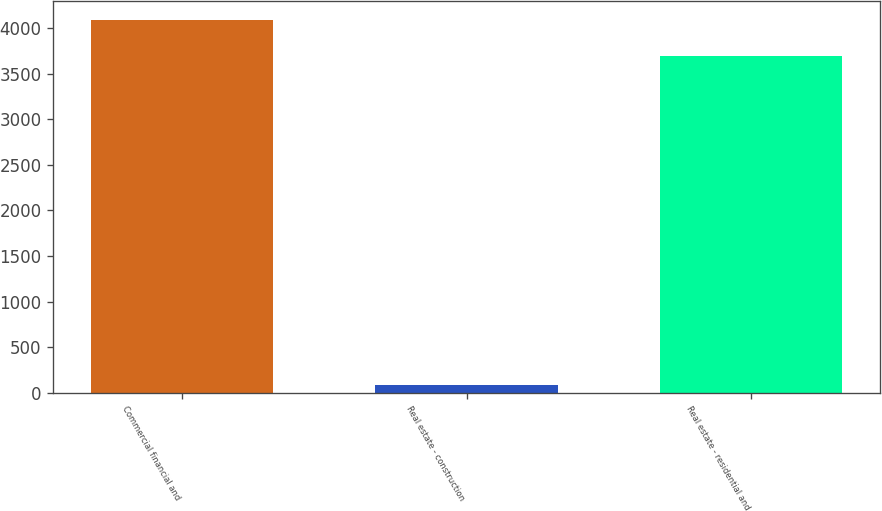<chart> <loc_0><loc_0><loc_500><loc_500><bar_chart><fcel>Commercial financial and<fcel>Real estate - construction<fcel>Real estate - residential and<nl><fcel>4086.9<fcel>91<fcel>3693<nl></chart> 